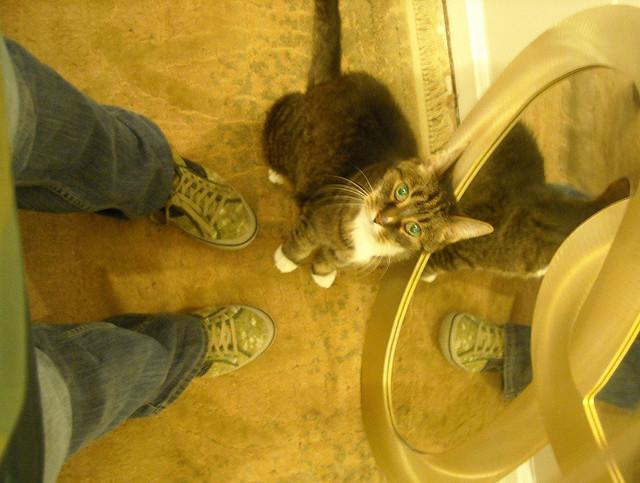Is this a dog?
Write a very short answer. No. Does the cat look startled?
Quick response, please. No. How many cats are there?
Keep it brief. 1. 